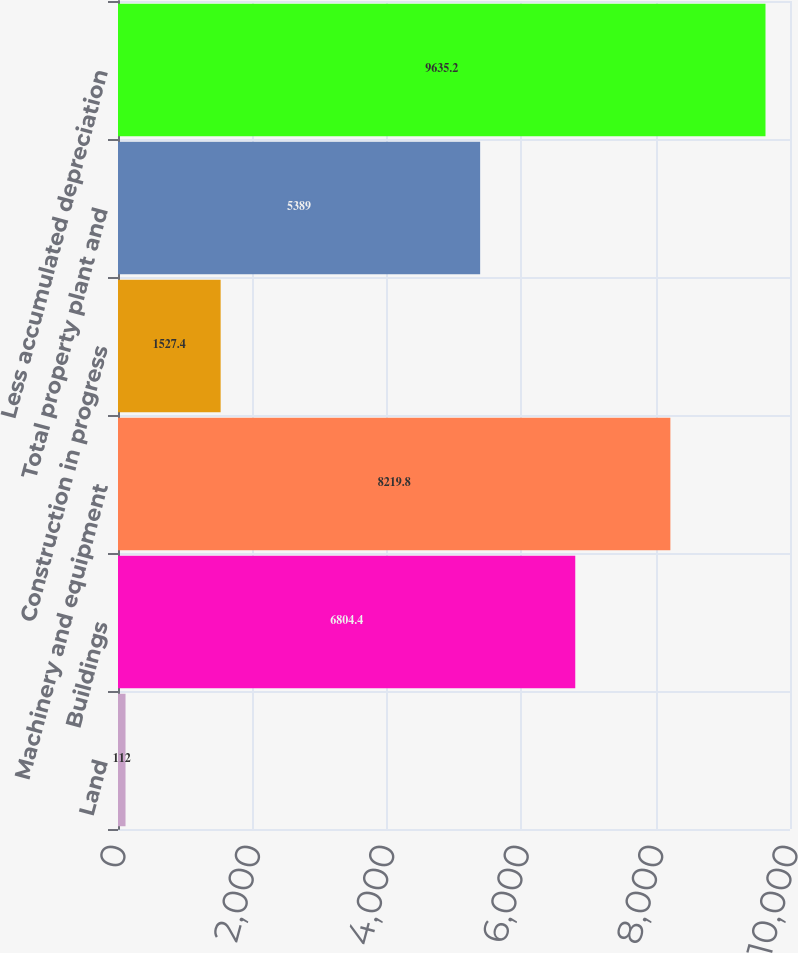Convert chart. <chart><loc_0><loc_0><loc_500><loc_500><bar_chart><fcel>Land<fcel>Buildings<fcel>Machinery and equipment<fcel>Construction in progress<fcel>Total property plant and<fcel>Less accumulated depreciation<nl><fcel>112<fcel>6804.4<fcel>8219.8<fcel>1527.4<fcel>5389<fcel>9635.2<nl></chart> 